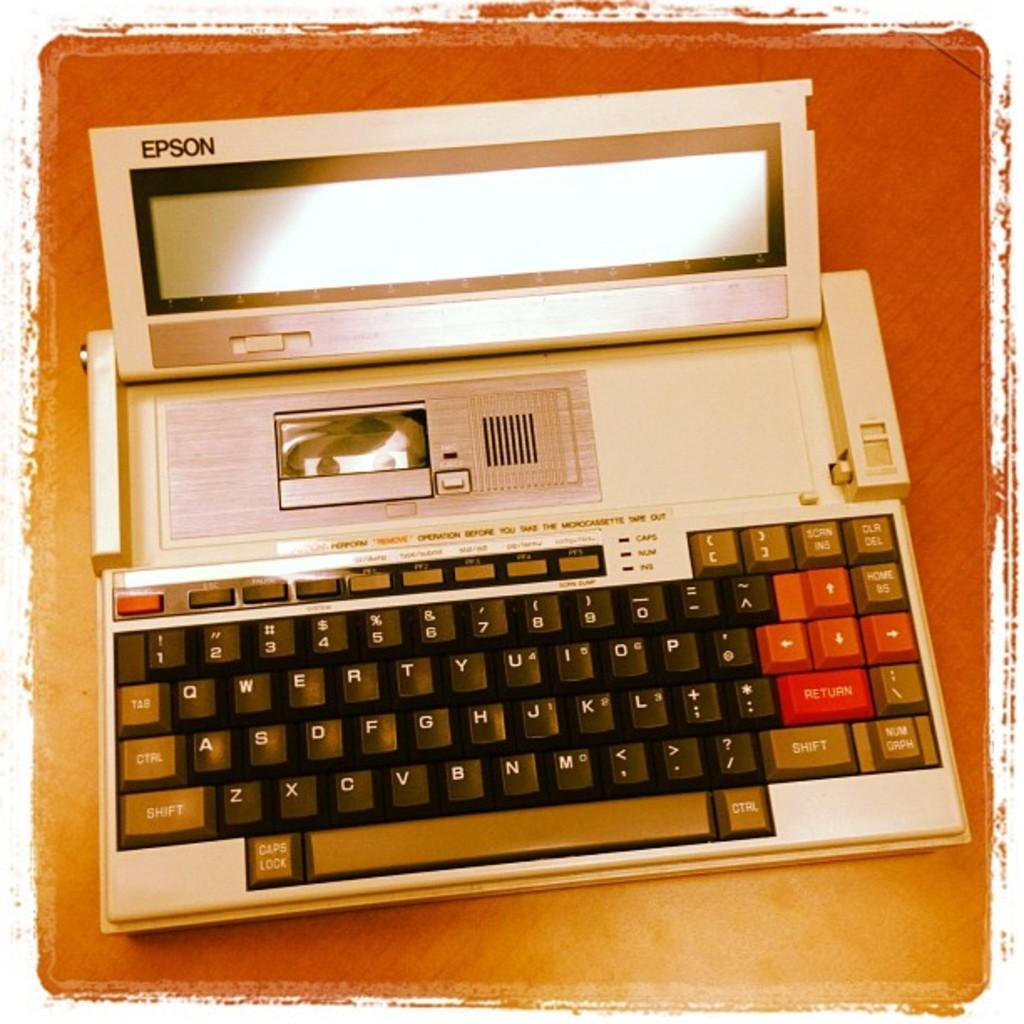What brand of device is this?
Your response must be concise. Epson. 